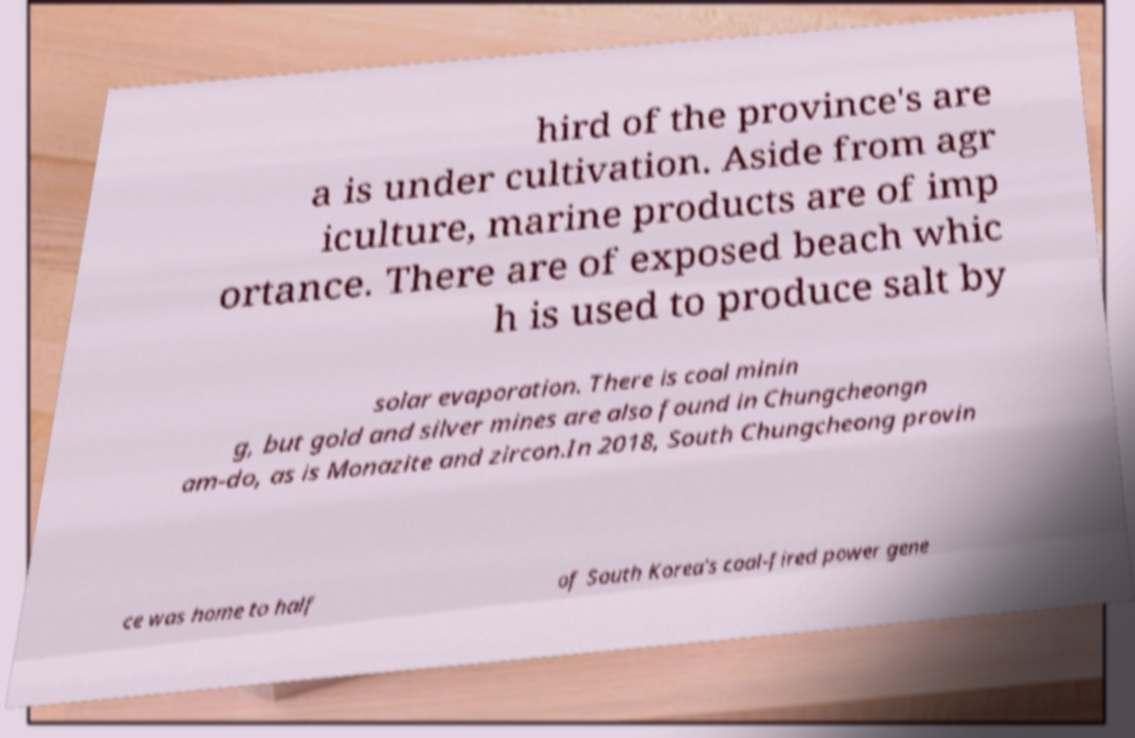I need the written content from this picture converted into text. Can you do that? hird of the province's are a is under cultivation. Aside from agr iculture, marine products are of imp ortance. There are of exposed beach whic h is used to produce salt by solar evaporation. There is coal minin g, but gold and silver mines are also found in Chungcheongn am-do, as is Monazite and zircon.In 2018, South Chungcheong provin ce was home to half of South Korea's coal-fired power gene 